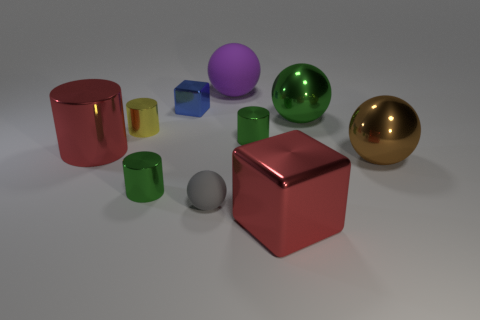Subtract all big green shiny spheres. How many spheres are left? 3 Subtract 3 cylinders. How many cylinders are left? 1 Subtract all red cylinders. How many cylinders are left? 3 Subtract 1 red cylinders. How many objects are left? 9 Subtract all balls. How many objects are left? 6 Subtract all brown balls. Subtract all red blocks. How many balls are left? 3 Subtract all green blocks. How many gray spheres are left? 1 Subtract all big red cylinders. Subtract all large purple spheres. How many objects are left? 8 Add 3 yellow objects. How many yellow objects are left? 4 Add 5 rubber things. How many rubber things exist? 7 